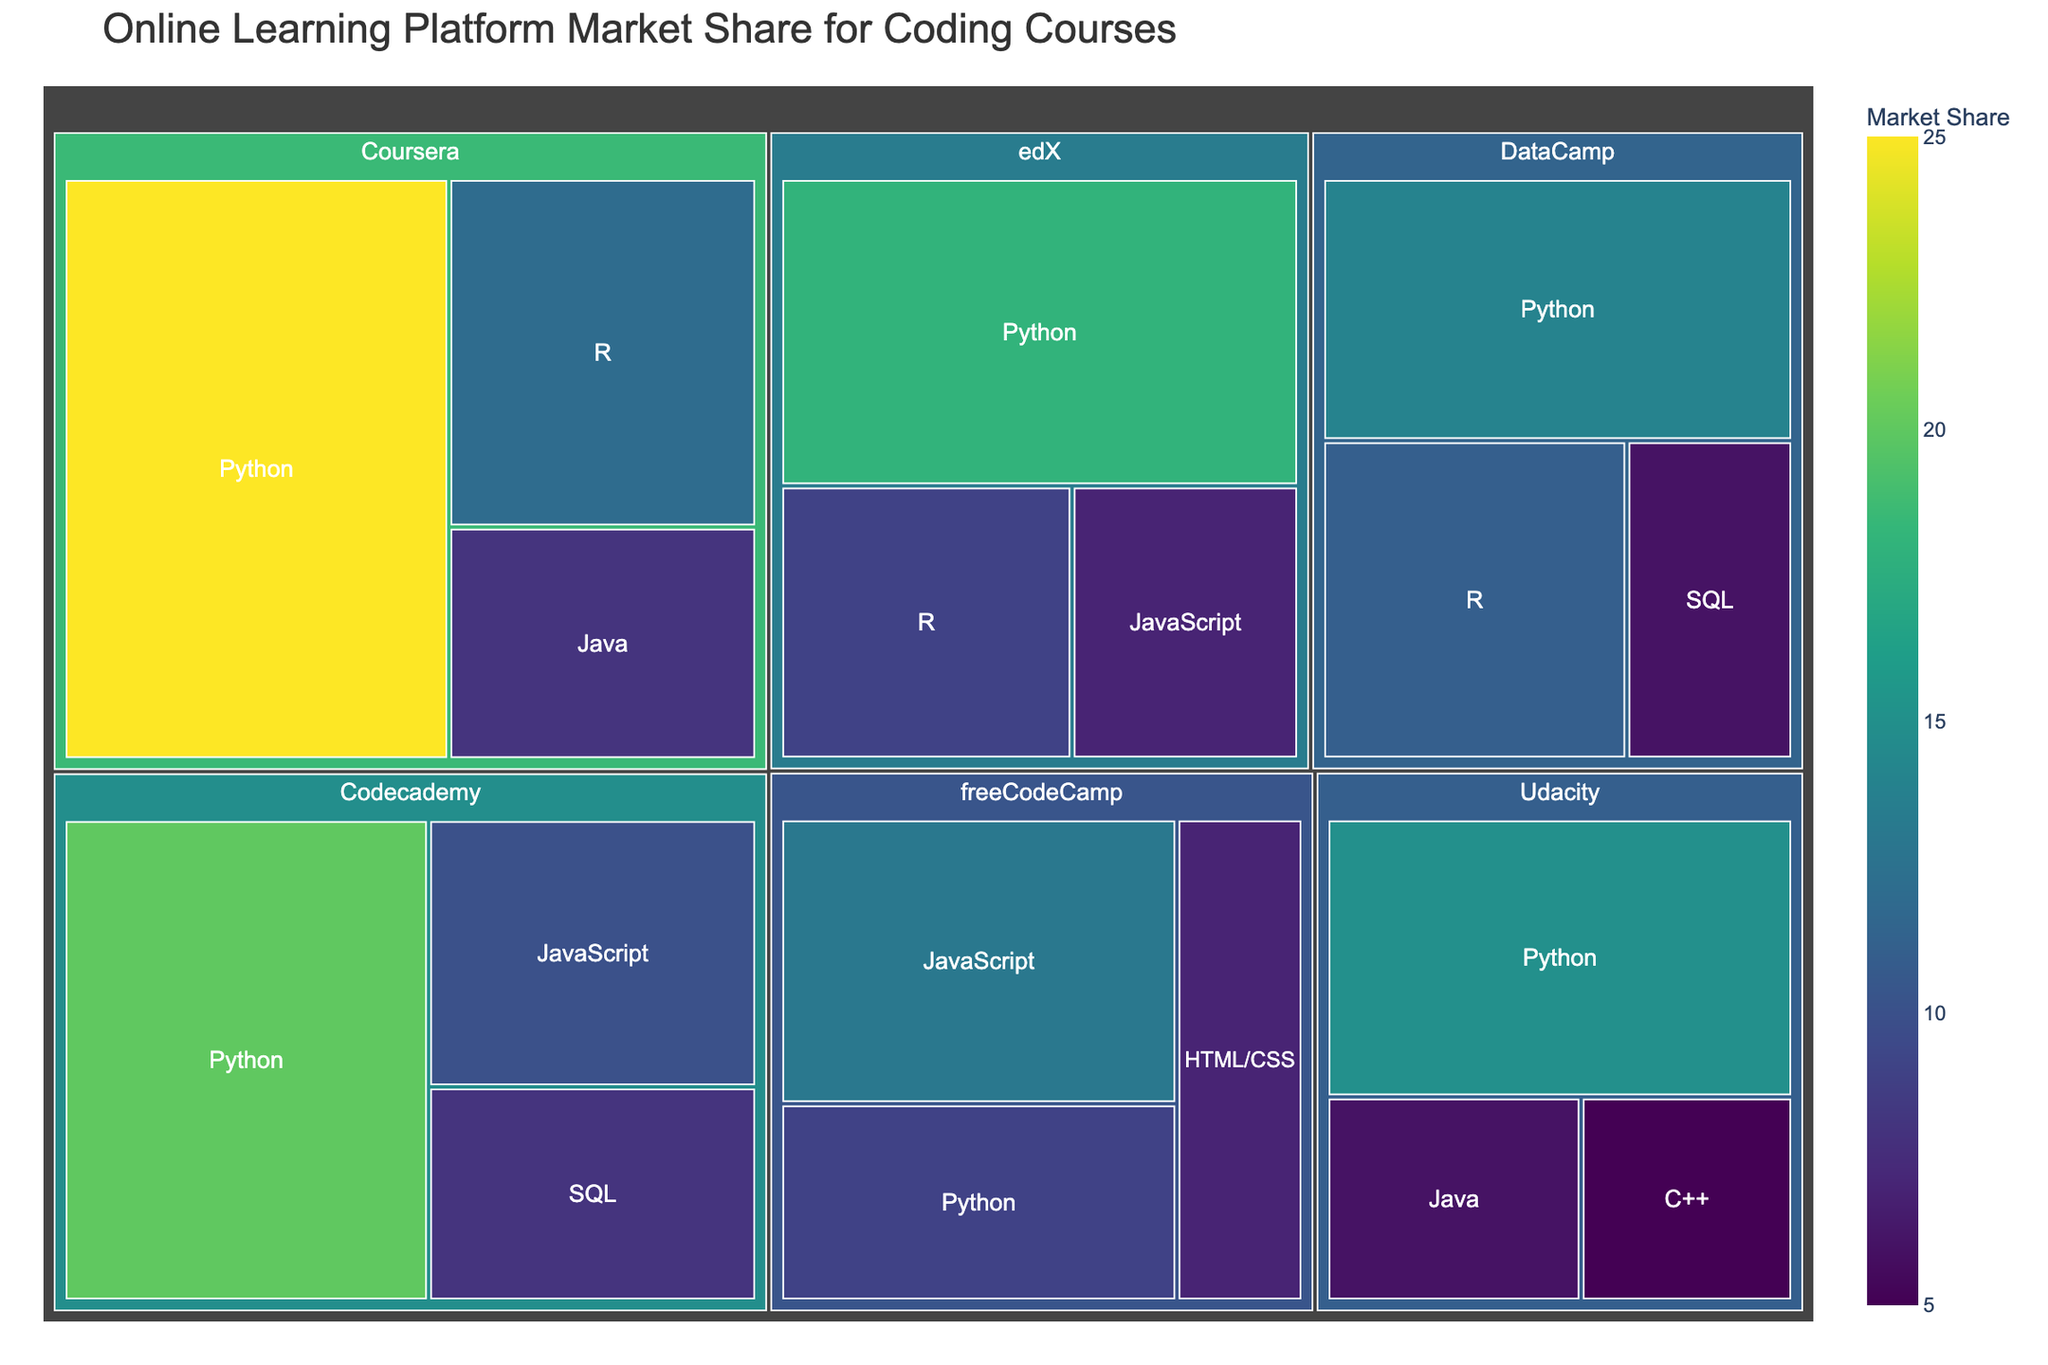What is the title of the treemap? The title is usually displayed at the top of the figure. In this case, it is "Online Learning Platform Market Share for Coding Courses" as specified in the code that generates the figure.
Answer: Online Learning Platform Market Share for Coding Courses Which platform has the largest market share for Python courses? To find the platform with the largest market share for Python courses, look for the largest segment labeled 'Python' and compare the values. Coursera has a value of 25 for Python, which is the largest compared to other platforms.
Answer: Coursera How many platforms offer Java courses? The subcategory 'Java' appears within segments for Coursera, edX, and Udacity. Count these platforms.
Answer: 3 Which subcategory has the smallest market share under DataCamp? Identify the smallest segment under DataCamp and find its corresponding subcategory. DataCamp offers Python (14), R (11), and SQL (6). The smallest value is 6 for SQL.
Answer: SQL What is the combined market share of Python courses across all platforms? Sum the values for Python courses across all platforms. The values are Coursera (25), edX (18), Udacity (15), Codecademy (20), DataCamp (14), freeCodeCamp (9). 25+18+15+20+14+9 = 101
Answer: 101 Which platform has a higher market share for R courses, edX, or DataCamp? Compare the values for R courses under edX and DataCamp. edX has a value of 9, DataCamp has a value of 11.
Answer: DataCamp Is the market share for Java courses on Coursera higher than the market share for SQL courses on Codecademy? Compare the value for Java on Coursera (8) with SQL on Codecademy (8). Both are equal.
Answer: No, they are equal How many subcategories does Codecademy offer courses in? Count the number of subcategories (nested blocks) under Codecademy. Codecademy has 3 subcategories: Python, JavaScript, and SQL.
Answer: 3 Which platform has the second largest market share for JavaScript courses? Identify platforms offering JavaScript courses, and compare their values. The platforms are edX (7), Codecademy (10), freeCodeCamp (13). The second largest value is 10 from Codecademy.
Answer: Codecademy What is the average market share of Python courses offered by edX and Udacity? Add the values for Python courses on edX (18) and Udacity (15) and then divide by 2. (18+15) / 2 = 16.5
Answer: 16.5 